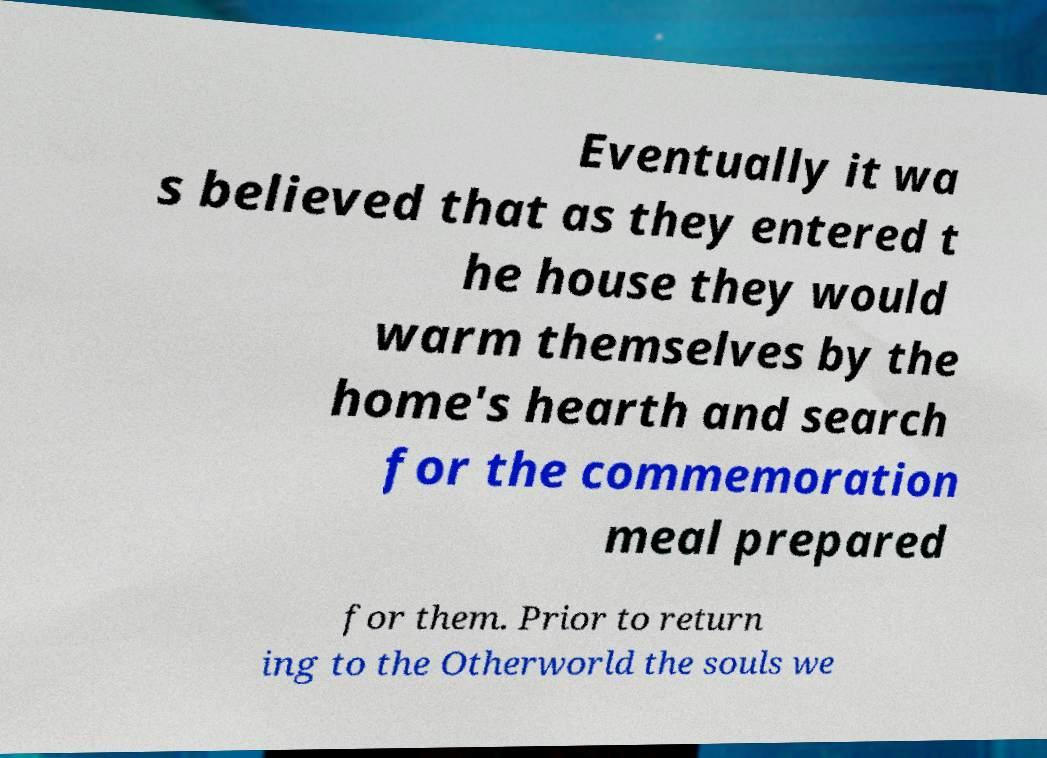I need the written content from this picture converted into text. Can you do that? Eventually it wa s believed that as they entered t he house they would warm themselves by the home's hearth and search for the commemoration meal prepared for them. Prior to return ing to the Otherworld the souls we 